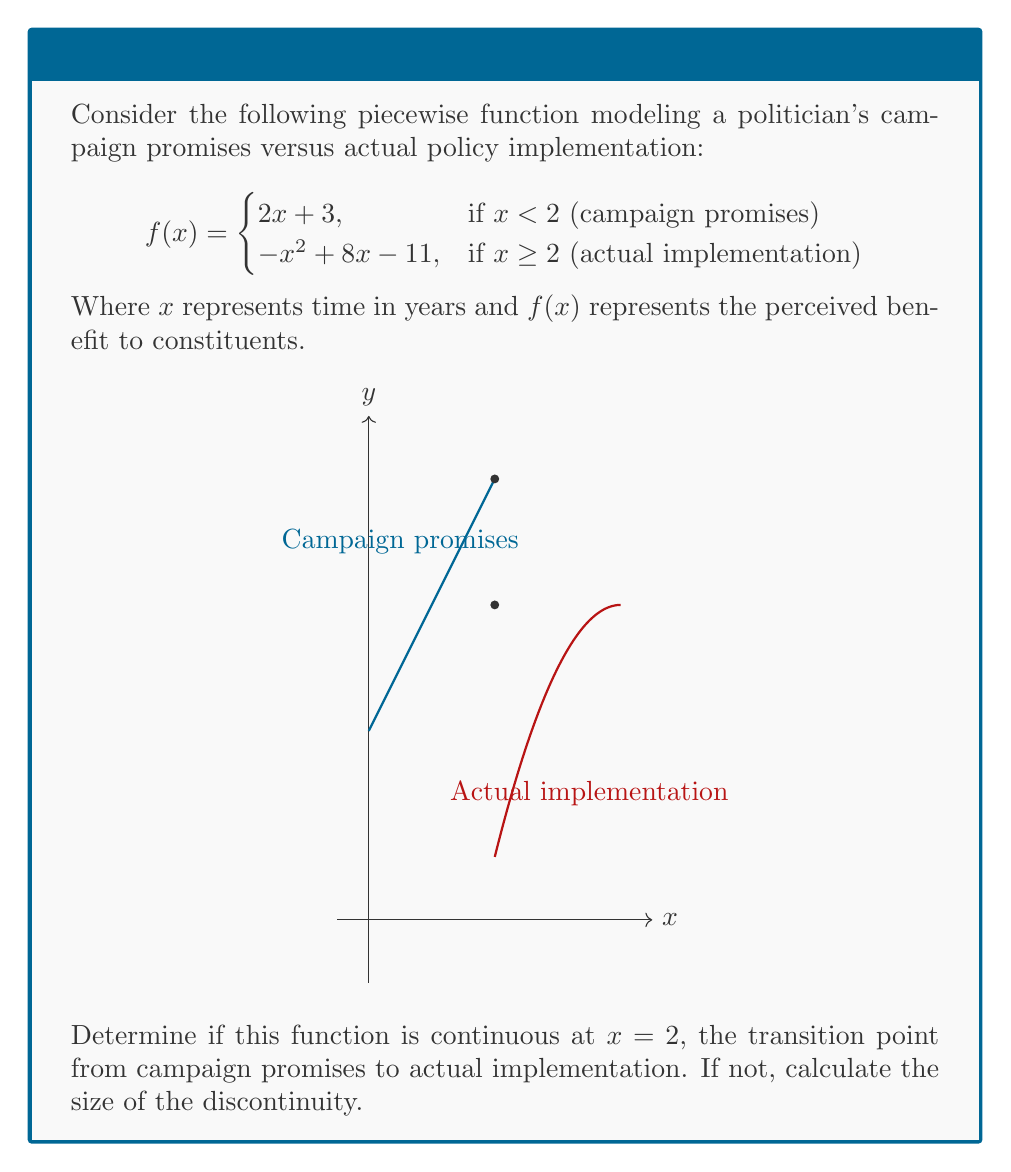Solve this math problem. To determine if the function is continuous at $x = 2$, we need to check three conditions:

1. $f(2)$ exists (the limit from the left exists)
2. $\lim_{x \to 2^+} f(x)$ exists (the limit from the right exists)
3. $f(2) = \lim_{x \to 2^+} f(x) = \lim_{x \to 2^-} f(x)$ (the function value equals both one-sided limits)

Step 1: Calculate $f(2)$ using the first piece of the function (campaign promises):
$f(2) = 2(2) + 3 = 7$

Step 2: Calculate $\lim_{x \to 2^-} f(x)$ (left-hand limit):
$\lim_{x \to 2^-} f(x) = \lim_{x \to 2^-} (2x + 3) = 2(2) + 3 = 7$

Step 3: Calculate $\lim_{x \to 2^+} f(x)$ (right-hand limit):
$\lim_{x \to 2^+} f(x) = \lim_{x \to 2^+} (-x^2 + 8x - 11) = -(2^2) + 8(2) - 11 = -4 + 16 - 11 = 1$

Step 4: Compare the results:
$f(2) = 7$
$\lim_{x \to 2^-} f(x) = 7$
$\lim_{x \to 2^+} f(x) = 1$

Since $f(2) \neq \lim_{x \to 2^+} f(x)$, the function is not continuous at $x = 2$.

Step 5: Calculate the size of the discontinuity:
Discontinuity = $|f(2) - \lim_{x \to 2^+} f(x)| = |7 - 1| = 6$

This discontinuity represents the discrepancy between campaign promises and actual policy implementation at the 2-year mark.
Answer: The function is discontinuous at $x = 2$ with a jump discontinuity of size 6. 